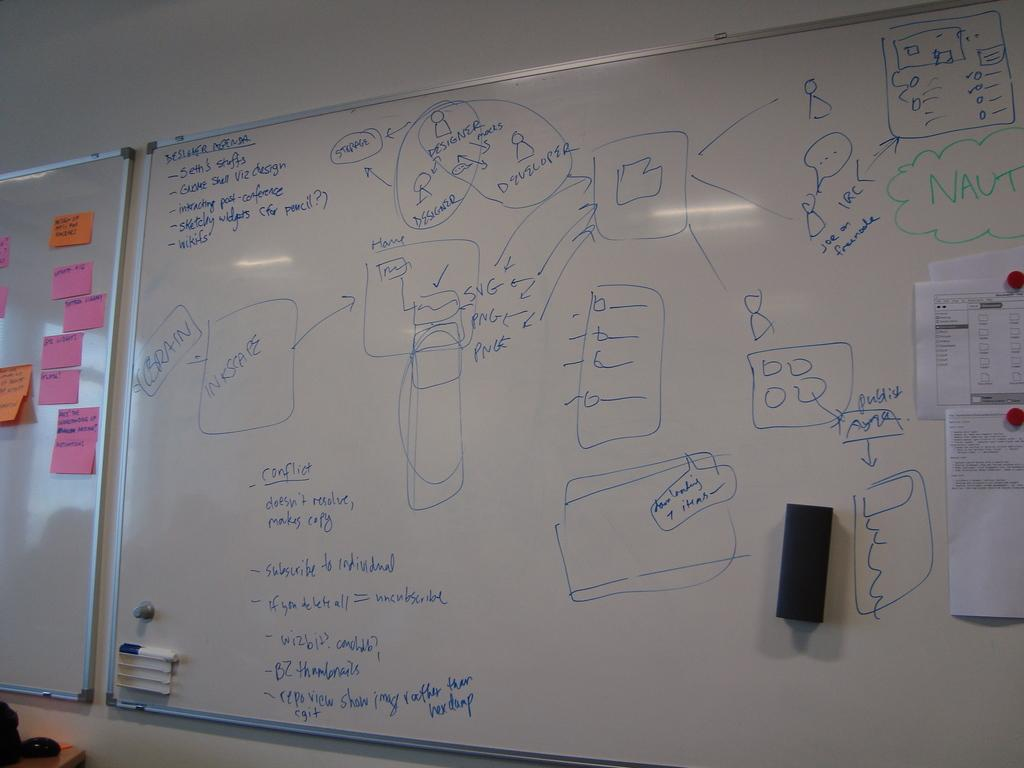<image>
Summarize the visual content of the image. "Conflict" is explained in detail on a white board. 